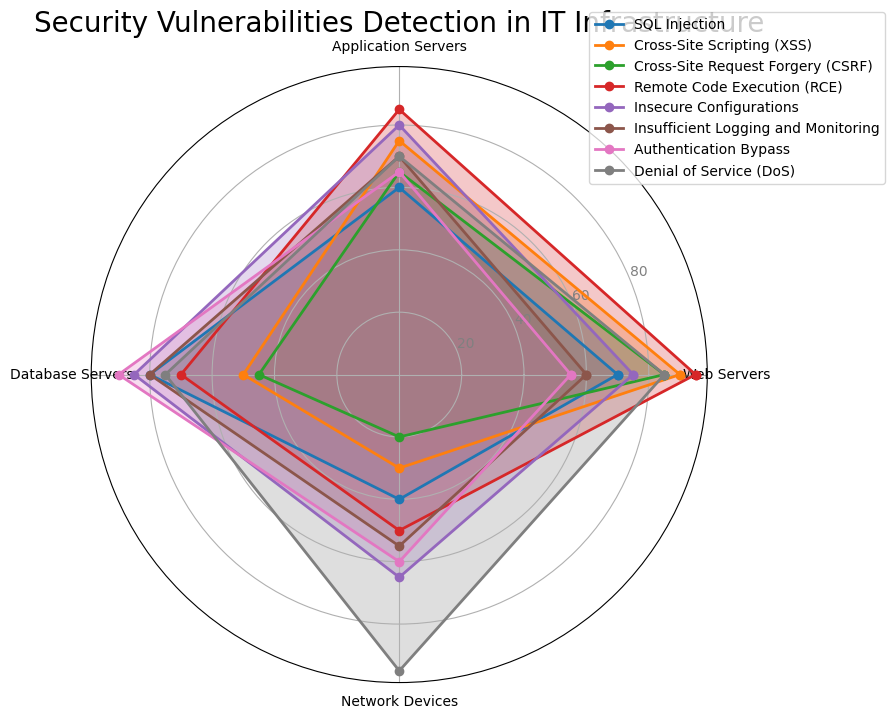Which category has the highest vulnerability detection for Web Servers? To determine which category has the highest vulnerability detection for Web Servers, we compare the values for all categories in the Web Servers column. Remote Code Execution (RCE) has the highest value (95)
Answer: Remote Code Execution (RCE) Which category has the lowest vulnerability detection for Network Devices? Look at the values for the Network Devices column and identify the lowest one. Cross-Site Request Forgery (CSRF) has the lowest value (20)
Answer: Cross-Site Request Forgery (CSRF) Compare the vulnerability detection for SQL Injection between Database Servers and Network Devices. Which one is higher? Check the SQL Injection values for both Database Servers (80) and Network Devices (40) and compare them. 80 is higher than 40
Answer: Database Servers What is the average detection rate of Cross-Site Scripting (XSS) across all server types? Add the detection rates of XSS for Web Servers (90), Application Servers (75), Database Servers (50), and Network Devices (30), then divide by 4. (90+75+50+30)/4 = 245/4
Answer: 61.25 Which vulnerability category shows equal detection rates for Web Servers and Application Servers? By comparing the values for all categories, find a matching pair for the two columns. Cross-Site Request Forgery (CSRF) shows 85 for Web Servers and 65 for Application Servers (they are not equal). No other categories show equal values.
Answer: None For Denial of Service (DoS), how much higher is the detection rate for network devices compared to application servers? Subtract the detection rate of DoS for Application Servers (70) from Network Devices (95). 95 - 70
Answer: 25 Combine the detection rates of Remote Code Execution (RCE) and Authentication Bypass for Web Servers. What is the total? Add the values for RCE (95) and Authentication Bypass (55) for Web Servers. 95 + 55
Answer: 150 Which category had the highest variability in detection rates across all server types? Identify the range for each category by subtracting the lowest value from the highest for each category and compare. For SQL Injection: 80-40=40, for XSS: 90-30=60, for CSRF: 85-20=65, for RCE: 95-50=45, for Insecure Configurations: 85-65=20, for Insufficient Logging: 80-55=25, for Authentication Bypass: 90-55=35, for DoS: 95-70=25. The highest range is for CSRF (65).
Answer: Cross-Site Request Forgery (CSRF) How many vulnerabilities are detected at a rate of 80 or above in Database Servers? Count the number of categories where the detection rate is 80 or higher for Database Servers: SQL Injection (80), Insecure Configurations (85), and Authentication Bypass (90), DoS (75) is not >= 80, Insufficient Logging and Monitoring (80). Thus, total is 4.
Answer: 4 